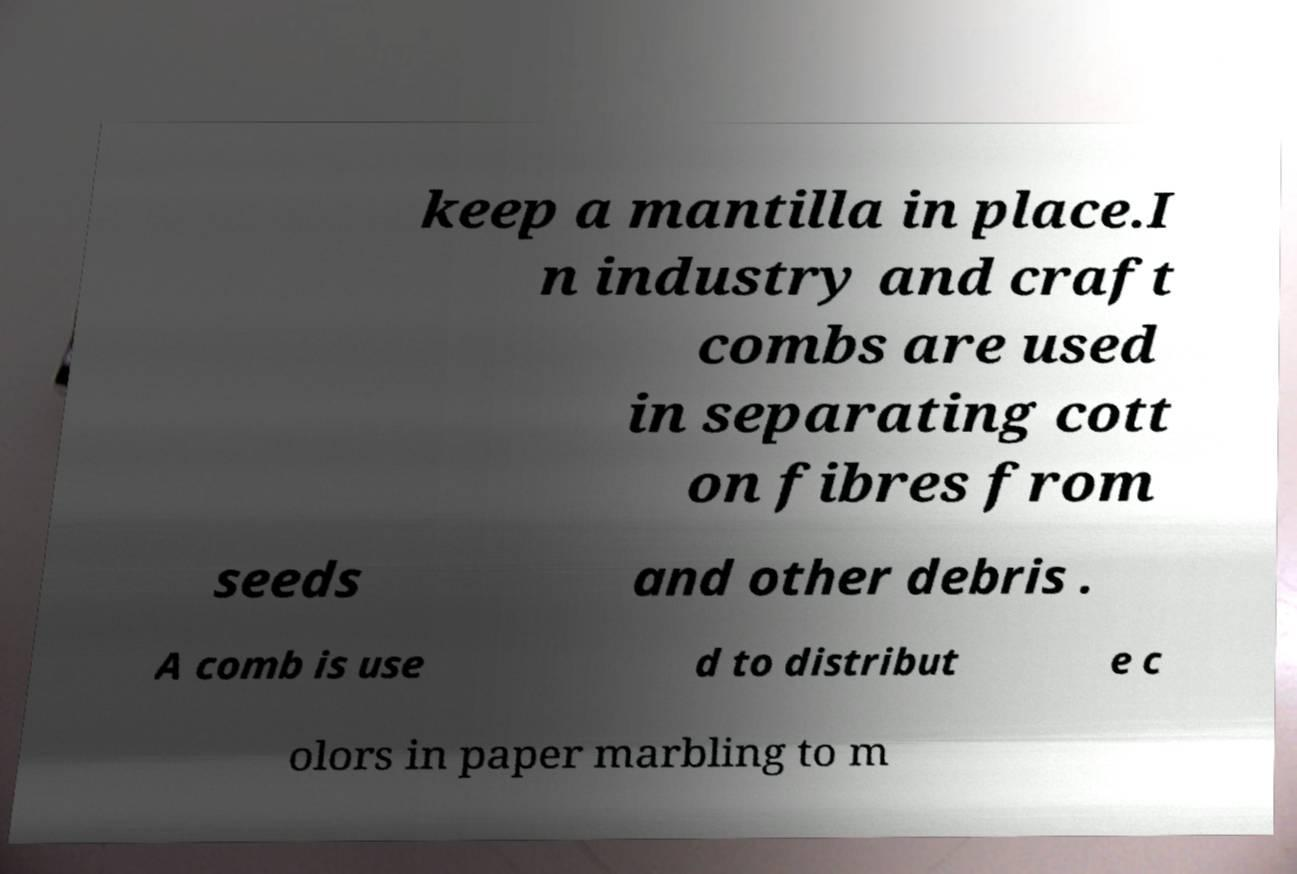I need the written content from this picture converted into text. Can you do that? keep a mantilla in place.I n industry and craft combs are used in separating cott on fibres from seeds and other debris . A comb is use d to distribut e c olors in paper marbling to m 